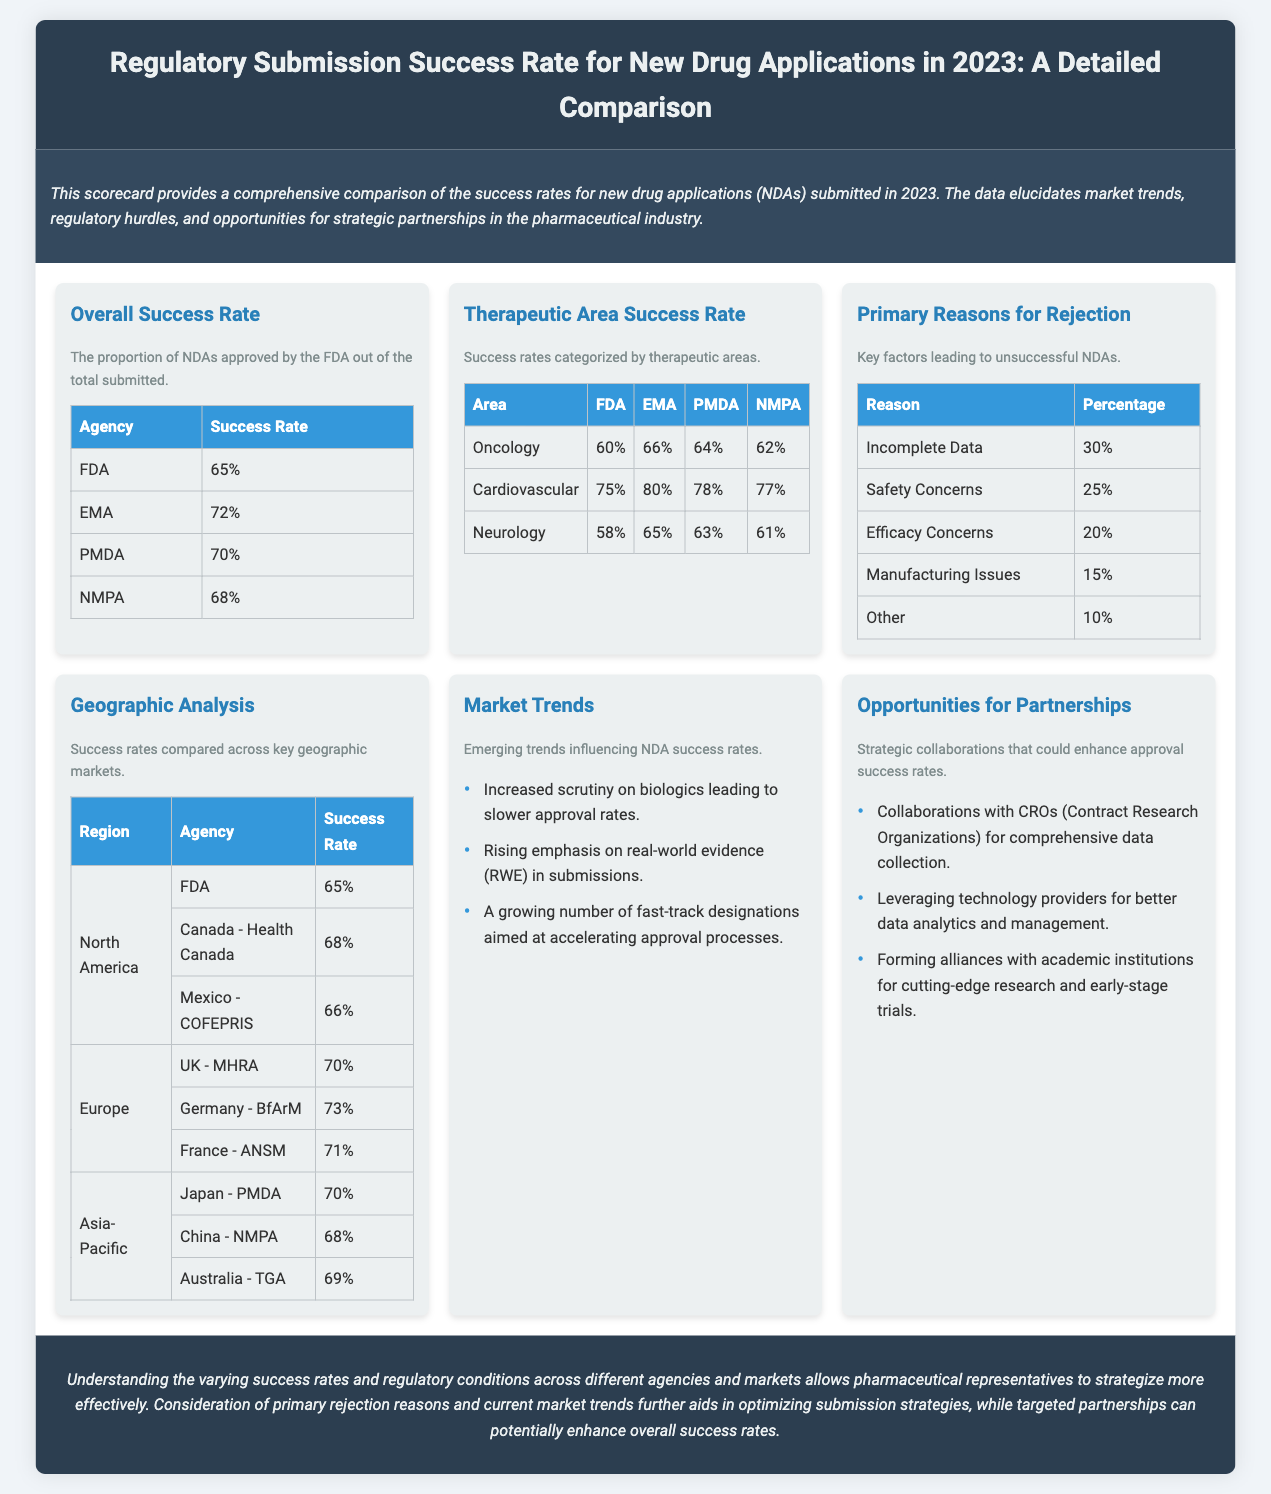What is the overall success rate of NDAs approved by the FDA? The overall success rate of NDAs approved by the FDA is listed in the document under the "Overall Success Rate" section.
Answer: 65% What percentage of NDAs fails due to incomplete data? The percentage of NDAs that failed due to incomplete data is provided in the "Primary Reasons for Rejection" section.
Answer: 30% Which agency has the highest success rate for NDAs? The success rates for NDAs are compared in the "Overall Success Rate" table; the agency with the highest rate is EMA.
Answer: 72% What is the success rate for oncology drugs according to the EMA? The success rate for oncology drugs is provided in the "Therapeutic Area Success Rate" table under EMA.
Answer: 66% What are the primary reasons cited for NDA rejections? The "Primary Reasons for Rejection" section lists the key factors leading to unsuccessful NDAs.
Answer: Incomplete Data, Safety Concerns, Efficacy Concerns, Manufacturing Issues, Other Which geographical region has the lowest success rate for NDAs? The success rates across regions can be found in the "Geographic Analysis" section; the region with the lowest rate is North America under FDA.
Answer: 65% What trend is influencing NDA success rates according to the document? The "Market Trends" section lists emerging trends influencing NDA success rates.
Answer: Increased scrutiny on biologics What is one of the partnership opportunities mentioned in the document? The "Opportunities for Partnerships" section discusses strategic collaborations that could enhance approval success rates.
Answer: Collaborations with CROs What therapeutic area shows the lowest success rate from the FDA? The success rates by therapeutic area are listed in the "Therapeutic Area Success Rate" table.
Answer: Neurology 